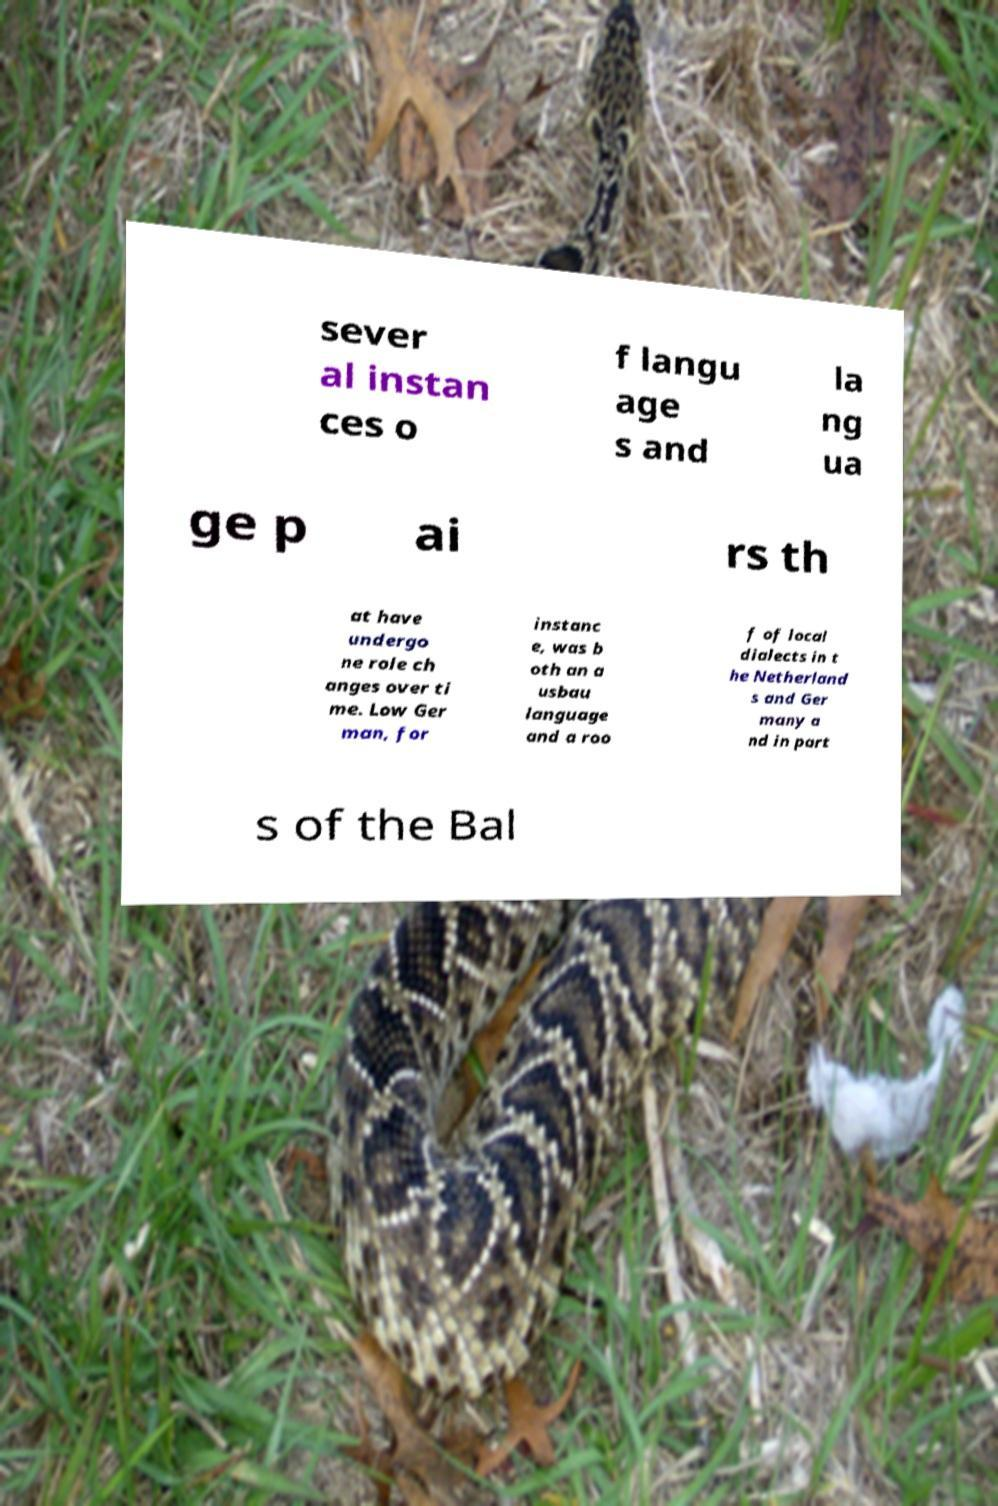Please read and relay the text visible in this image. What does it say? sever al instan ces o f langu age s and la ng ua ge p ai rs th at have undergo ne role ch anges over ti me. Low Ger man, for instanc e, was b oth an a usbau language and a roo f of local dialects in t he Netherland s and Ger many a nd in part s of the Bal 